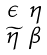<formula> <loc_0><loc_0><loc_500><loc_500>\begin{smallmatrix} \epsilon & \eta \\ \widetilde { \eta } & \beta \end{smallmatrix}</formula> 